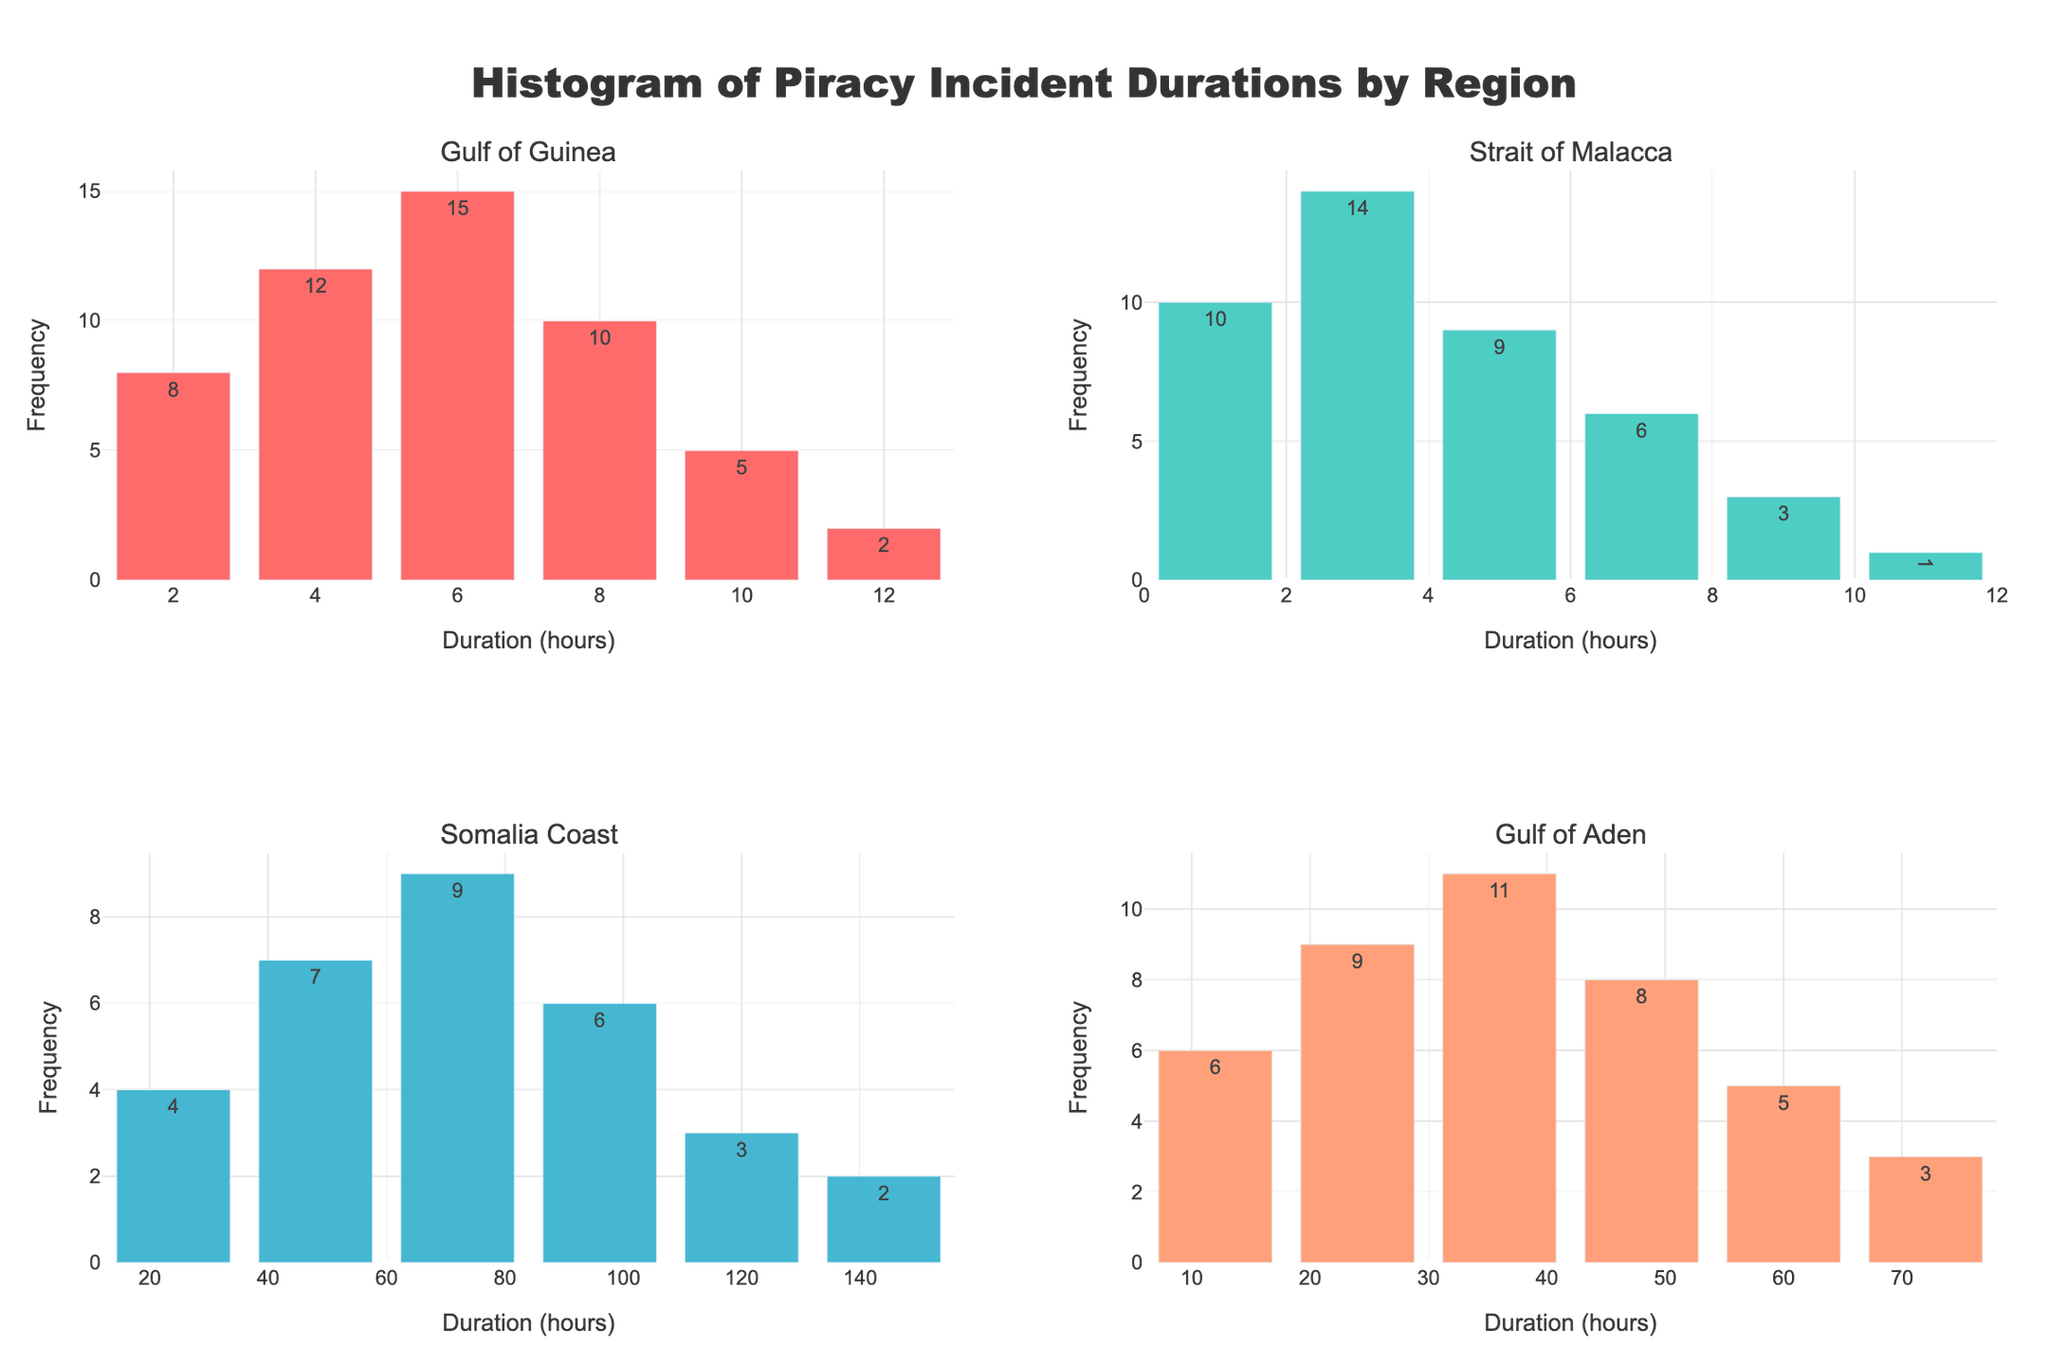What is the title of the figure? The title of the figure is placed at the top center and reads "Histogram of Piracy Incident Durations by Region".
Answer: Histogram of Piracy Incident Durations by Region Which region has the highest frequency for a specific duration, and what is that frequency? By examining the histograms, the Gulf of Guinea has the highest individual frequency for a specific duration of 6 hours with a frequency of 15.
Answer: Gulf of Guinea, 15 How many regions are compared in the figure? There are four regions compared in the figure, as evident from the four histograms labeled Gulf of Guinea, Strait of Malacca, Somalia Coast, and Gulf of Aden.
Answer: 4 What is the duration with the lowest frequency in the Somalia Coast region, and what is that frequency? In the Somalia Coast region, durations of 120 hours and 144 hours both have the lowest frequencies of 2.
Answer: 120 hours and 144 hours, 2 Compare the frequency of piracy incidents of 24 hours duration between Somalia Coast and Gulf of Aden. Which one is higher? By examining the histograms, Somalia Coast has a frequency of 7 for 24 hours, whereas Gulf of Aden has a frequency of 9 for the same duration. Therefore, Gulf of Aden has the higher frequency.
Answer: Gulf of Aden Which subplot has the most varied durations of piracy incidents? The Somalia Coast histogram shows piracy incident durations ranging from 24 to 144 hours, indicating the most variety compared to other subplots.
Answer: Somalia Coast What is the color used to represent the Gulf of Aden region in the plots? The Gulf of Aden region is represented in the subplot by the color light salmon (hex code: #FFA07A).
Answer: light salmon Which region has the shortest average piracy incident duration based on the histogram? Examining the frequencies, the Strait of Malacca region has the shortest average piracy incident duration because its durations vary mainly between 1 and 11 hours.
Answer: Strait of Malacca Identify the subplot where piracy incidents' durations are predominantly above 12 hours. The histogram for the Somalia Coast region shows durations predominantly above 12 hours when compared to the other regions.
Answer: Somalia Coast 